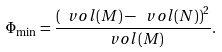Convert formula to latex. <formula><loc_0><loc_0><loc_500><loc_500>\Phi _ { \min } = \frac { \left ( \ v o l ( M ) - \ v o l ( N ) \right ) ^ { 2 } } { \ v o l ( M ) } .</formula> 